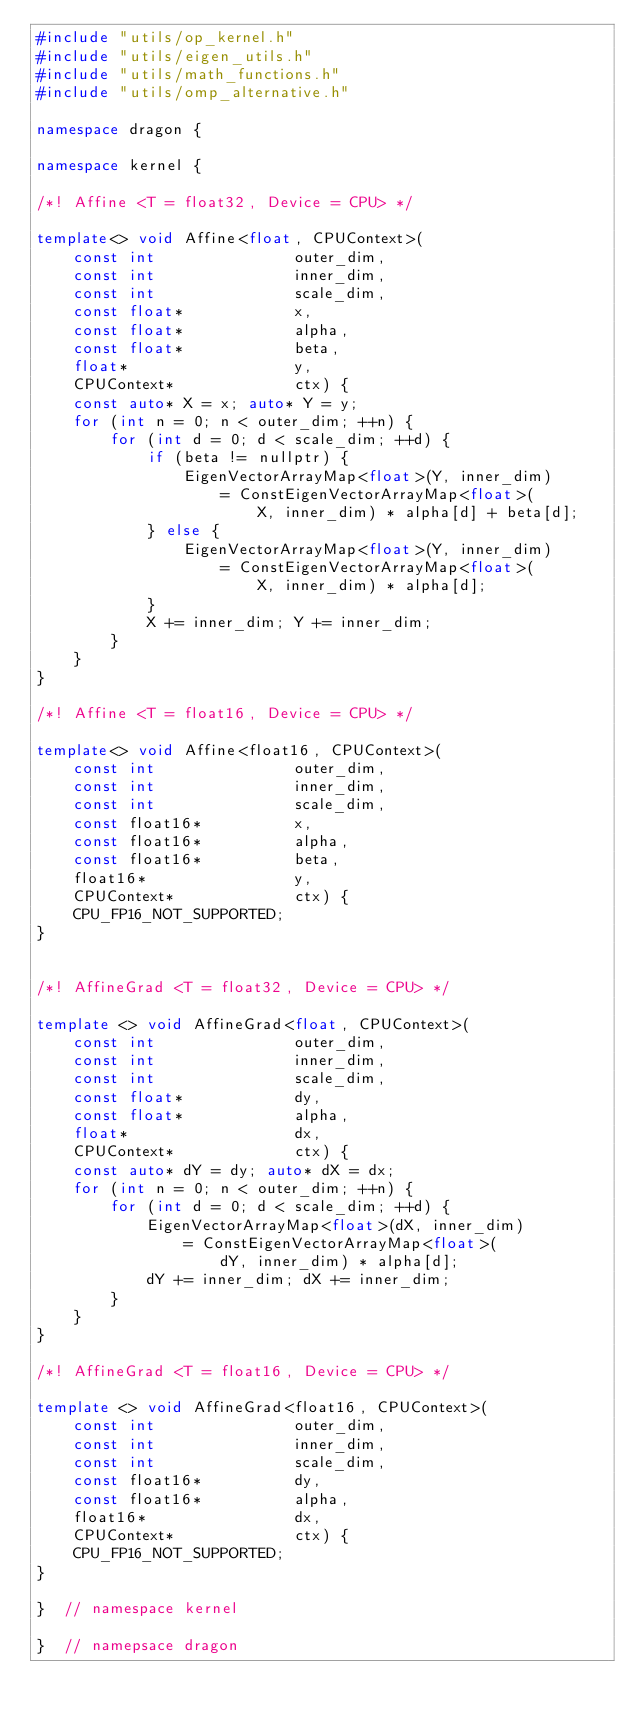Convert code to text. <code><loc_0><loc_0><loc_500><loc_500><_C++_>#include "utils/op_kernel.h"
#include "utils/eigen_utils.h"
#include "utils/math_functions.h"
#include "utils/omp_alternative.h"

namespace dragon {

namespace kernel {

/*! Affine <T = float32, Device = CPU> */

template<> void Affine<float, CPUContext>(
    const int               outer_dim,
    const int               inner_dim,
    const int               scale_dim,
    const float*            x,
    const float*            alpha,
    const float*            beta,
    float*                  y,
    CPUContext*             ctx) {
    const auto* X = x; auto* Y = y;
    for (int n = 0; n < outer_dim; ++n) {
        for (int d = 0; d < scale_dim; ++d) {
            if (beta != nullptr) {
                EigenVectorArrayMap<float>(Y, inner_dim)
                    = ConstEigenVectorArrayMap<float>(
                        X, inner_dim) * alpha[d] + beta[d];
            } else {
                EigenVectorArrayMap<float>(Y, inner_dim)
                    = ConstEigenVectorArrayMap<float>(
                        X, inner_dim) * alpha[d];
            }
            X += inner_dim; Y += inner_dim;
        }
    }
}

/*! Affine <T = float16, Device = CPU> */

template<> void Affine<float16, CPUContext>(
    const int               outer_dim,
    const int               inner_dim,
    const int               scale_dim,
    const float16*          x,
    const float16*          alpha,
    const float16*          beta,
    float16*                y,
    CPUContext*             ctx) {
    CPU_FP16_NOT_SUPPORTED;
}


/*! AffineGrad <T = float32, Device = CPU> */

template <> void AffineGrad<float, CPUContext>(
    const int               outer_dim,
    const int               inner_dim,
    const int               scale_dim,
    const float*            dy,
    const float*            alpha,
    float*                  dx,
    CPUContext*             ctx) {
    const auto* dY = dy; auto* dX = dx;
    for (int n = 0; n < outer_dim; ++n) {
        for (int d = 0; d < scale_dim; ++d) {
            EigenVectorArrayMap<float>(dX, inner_dim)
                = ConstEigenVectorArrayMap<float>(
                    dY, inner_dim) * alpha[d];
            dY += inner_dim; dX += inner_dim;
        }
    }
}

/*! AffineGrad <T = float16, Device = CPU> */

template <> void AffineGrad<float16, CPUContext>(
    const int               outer_dim,
    const int               inner_dim,
    const int               scale_dim,
    const float16*          dy,
    const float16*          alpha,
    float16*                dx,
    CPUContext*             ctx) {
    CPU_FP16_NOT_SUPPORTED;
}

}  // namespace kernel

}  // namepsace dragon</code> 